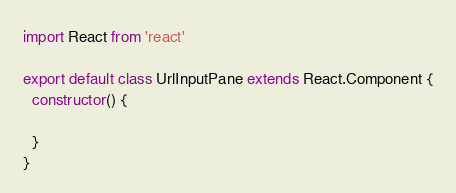<code> <loc_0><loc_0><loc_500><loc_500><_JavaScript_>import React from 'react'

export default class UrlInputPane extends React.Component {
  constructor() {
    
  }
}
</code> 